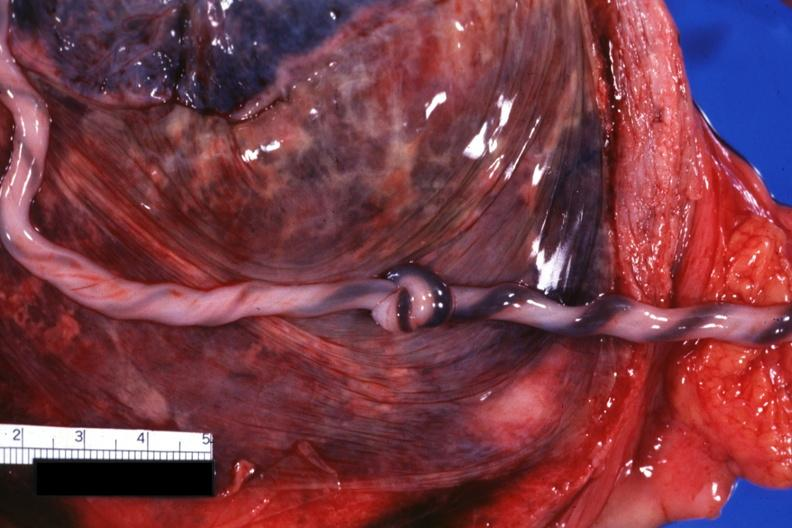s amyloidosis present?
Answer the question using a single word or phrase. No 